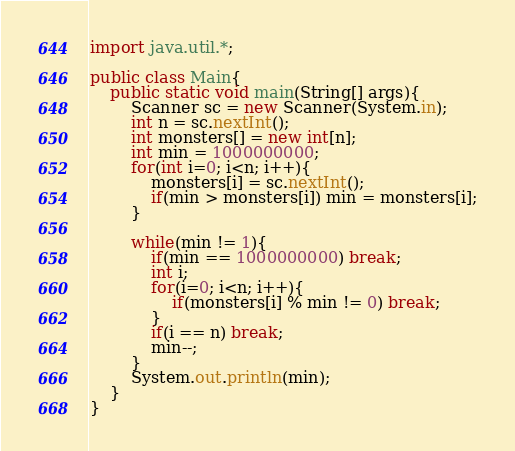Convert code to text. <code><loc_0><loc_0><loc_500><loc_500><_Java_>import java.util.*;

public class Main{
    public static void main(String[] args){
        Scanner sc = new Scanner(System.in);
        int n = sc.nextInt();
        int monsters[] = new int[n];
        int min = 1000000000;
        for(int i=0; i<n; i++){
            monsters[i] = sc.nextInt();
            if(min > monsters[i]) min = monsters[i];
        }

        while(min != 1){
          	if(min == 1000000000) break;
            int i;
            for(i=0; i<n; i++){
                if(monsters[i] % min != 0) break;
            }
            if(i == n) break;
            min--;
        }
        System.out.println(min);
    }
}</code> 